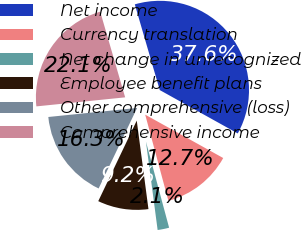<chart> <loc_0><loc_0><loc_500><loc_500><pie_chart><fcel>Net income<fcel>Currency translation<fcel>Net change in unrecognized<fcel>Employee benefit plans<fcel>Other comprehensive (loss)<fcel>Comprehensive income<nl><fcel>37.59%<fcel>12.74%<fcel>2.09%<fcel>9.19%<fcel>16.29%<fcel>22.11%<nl></chart> 